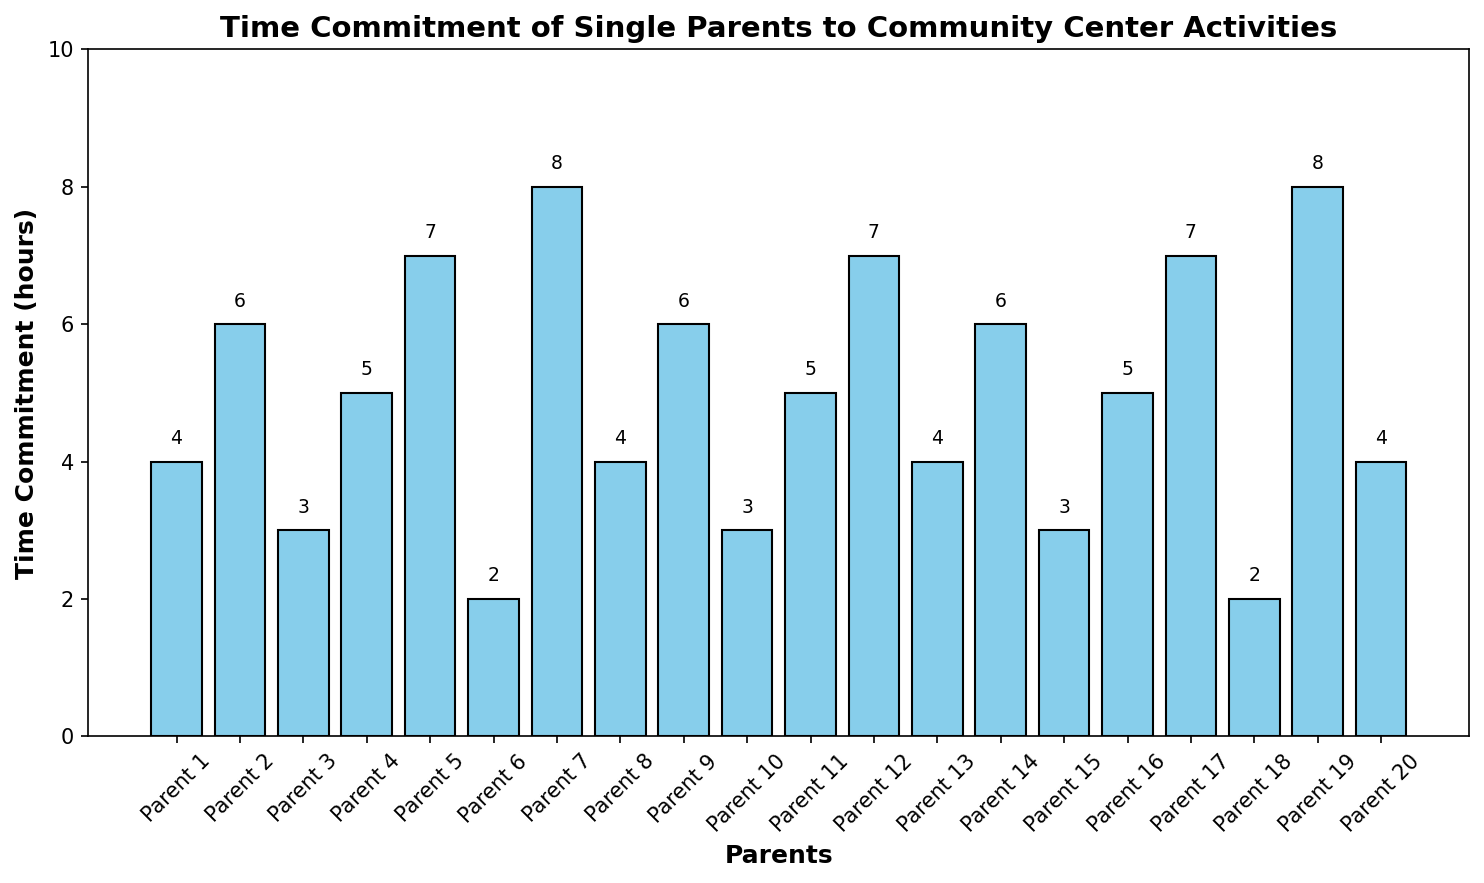What's the median time commitment for the single parents? To find the median, first list all the time commitments in ascending order: 2, 2, 3, 3, 3, 4, 4, 4, 4, 5, 5, 5, 5, 6, 6, 6, 7, 7, 7, 8. There are 20 values, so the median is the average of the 10th and 11th values: (5 + 5) / 2 = 5.
Answer: 5 Which parent has the highest time commitment? By observing the highest bars in the chart, we can see that Parent 7 and Parent 19 both have the highest time commitment of 8 hours.
Answer: Parent 7 and Parent 19 How many parents spend more than 5 hours per week on community center activities? By counting the bars higher than the 5-hour mark, we find that Parents 5, 7, 12, 17, and 19 spend more than 5 hours. That's 5 parents.
Answer: 5 What is the average time commitment of the parents? Add up all the time commitments and divide by the number of parents: (4 + 6 + 3 + 5 + 7 + 2 + 8 + 4 + 6 + 3 + 5 + 7 + 4 + 6 + 3 + 5 + 7 + 2 + 8 + 4) / 20 = 100 / 20 = 5.
Answer: 5 Which parents spend exactly 4 hours per week on community center activities? By checking the heights of the bars corresponding to 4 hours, we find Parents 1, 8, 13, and 20.
Answer: Parent 1, Parent 8, Parent 13, and Parent 20 What is the total time commitment of the parents who spend less than 4 hours per week on community center activities? Sum the time commitments of Parents 3, 6, 10, 15, and 18: 3 + 2 + 3 + 3 + 2 = 13.
Answer: 13 Compare the total time commitment of parents spending 6 hours per week to those spending 3 hours per week. Which group spends more? Sum the time commitments of parents spending 6 hours (Parents 2, 9, and 14): 6 + 6 + 6 = 18. Sum the time commitments of parents spending 3 hours (Parents 3, 10, and 15): 3 + 3 + 3 = 9. The group spending 6 hours has a higher total time commitment.
Answer: Parents spending 6 hours What's the range of time commitment among the parents? The range is found by subtracting the smallest value from the largest value: 8 - 2 = 6.
Answer: 6 Which three parents spend the least amount of time on community center activities? The parents with the smallest bars are Parent 6 and Parent 18 (both 2 hours), and then Parent 3, Parent 10, and Parent 15 (all 3 hours). Since we need only three, we choose the ones with 2 hours first and then any one of those with 3 hours.
Answer: Parent 6, Parent 18, and Parent 3 Which parents have a time commitment equal to or greater than the average time commitment? As calculated earlier, the average time commitment is 5 hours. Parents with commitments of 5 hours or more are Parents 2, 4, 5, 7, 9, 11, 12, 14, 16, 17, and 19.
Answer: Parent 2, Parent 4, Parent 5, Parent 7, Parent 9, Parent 11, Parent 12, Parent 14, Parent 16, Parent 17, and Parent 19 